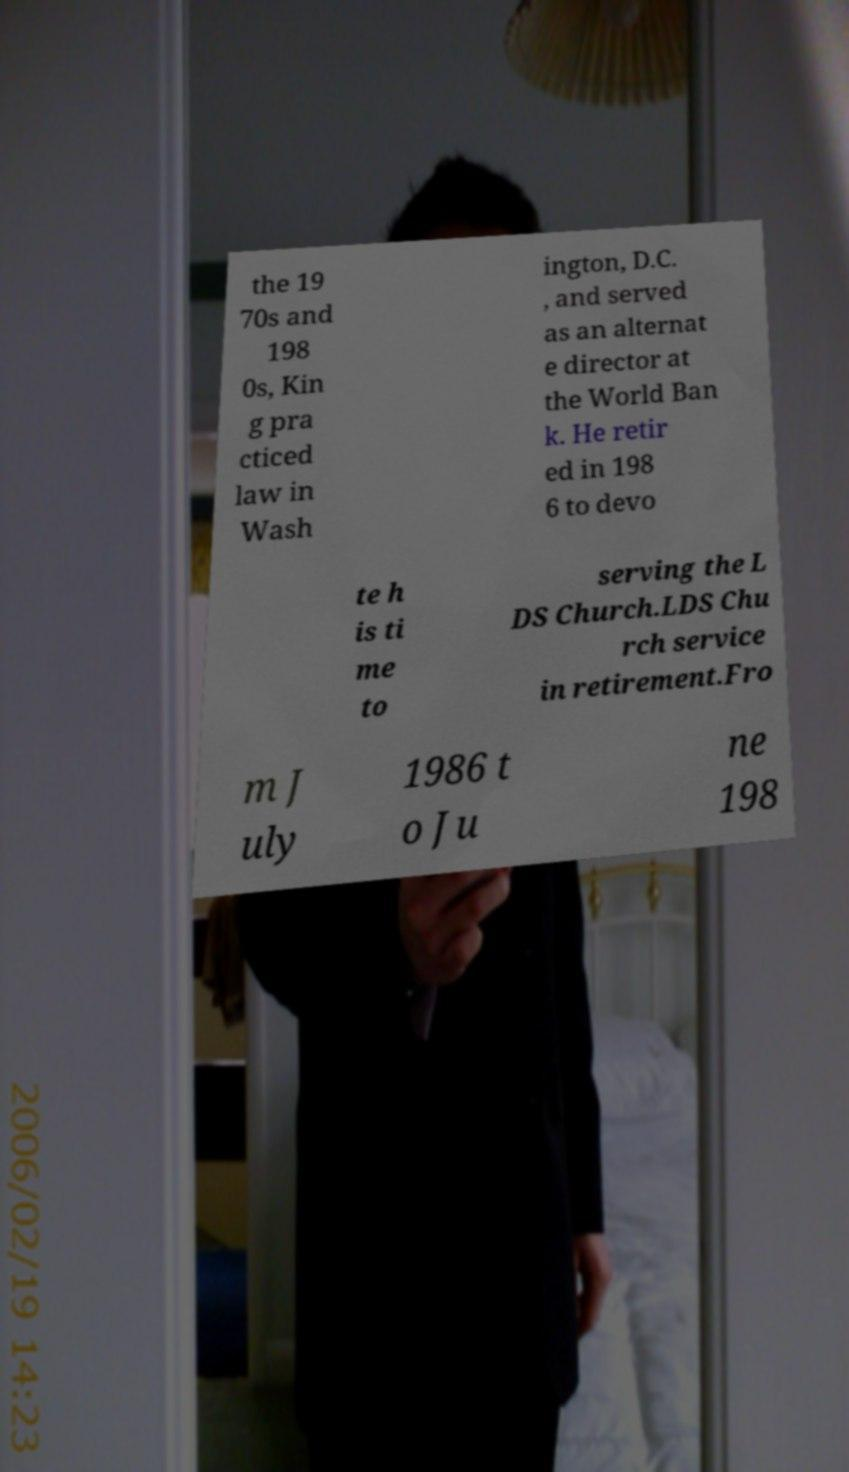I need the written content from this picture converted into text. Can you do that? the 19 70s and 198 0s, Kin g pra cticed law in Wash ington, D.C. , and served as an alternat e director at the World Ban k. He retir ed in 198 6 to devo te h is ti me to serving the L DS Church.LDS Chu rch service in retirement.Fro m J uly 1986 t o Ju ne 198 